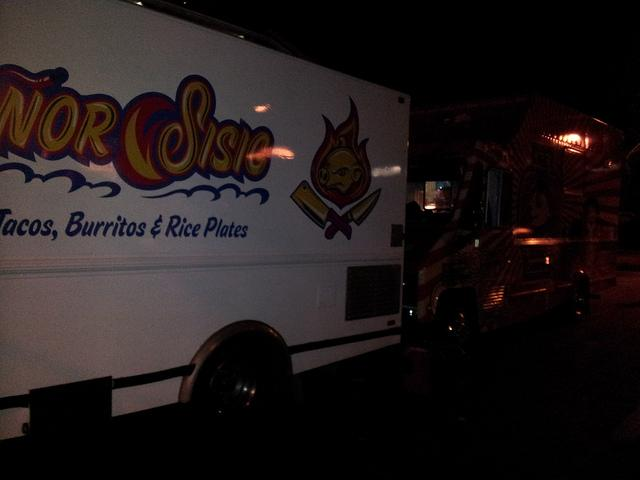What does the white truck do? food truck 